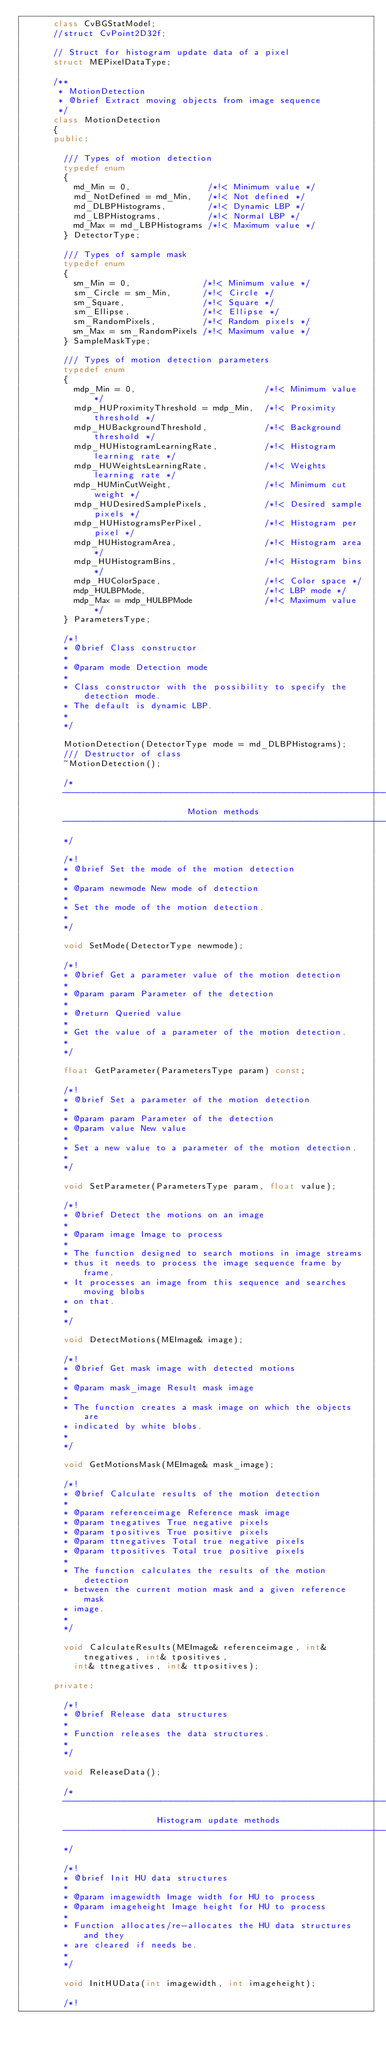Convert code to text. <code><loc_0><loc_0><loc_500><loc_500><_C++_>      class CvBGStatModel;
      //struct CvPoint2D32f;

      // Struct for histogram update data of a pixel
      struct MEPixelDataType;

      /**
       * MotionDetection
       * @brief Extract moving objects from image sequence
       */
      class MotionDetection
      {
      public:

        /// Types of motion detection
        typedef enum
        {
          md_Min = 0,               /*!< Minimum value */
          md_NotDefined = md_Min,   /*!< Not defined */
          md_DLBPHistograms,        /*!< Dynamic LBP */
          md_LBPHistograms,         /*!< Normal LBP */
          md_Max = md_LBPHistograms /*!< Maximum value */
        } DetectorType;

        /// Types of sample mask
        typedef enum
        {
          sm_Min = 0,              /*!< Minimum value */
          sm_Circle = sm_Min,      /*!< Circle */
          sm_Square,               /*!< Square */
          sm_Ellipse,              /*!< Ellipse */
          sm_RandomPixels,         /*!< Random pixels */
          sm_Max = sm_RandomPixels /*!< Maximum value */
        } SampleMaskType;

        /// Types of motion detection parameters
        typedef enum
        {
          mdp_Min = 0,                         /*!< Minimum value */
          mdp_HUProximityThreshold = mdp_Min,  /*!< Proximity threshold */
          mdp_HUBackgroundThreshold,           /*!< Background threshold */
          mdp_HUHistogramLearningRate,         /*!< Histogram learning rate */
          mdp_HUWeightsLearningRate,           /*!< Weights learning rate */
          mdp_HUMinCutWeight,                  /*!< Minimum cut weight */
          mdp_HUDesiredSamplePixels,           /*!< Desired sample pixels */
          mdp_HUHistogramsPerPixel,            /*!< Histogram per pixel */
          mdp_HUHistogramArea,                 /*!< Histogram area */
          mdp_HUHistogramBins,                 /*!< Histogram bins */
          mdp_HUColorSpace,                    /*!< Color space */
          mdp_HULBPMode,                       /*!< LBP mode */
          mdp_Max = mdp_HULBPMode              /*!< Maximum value */
        } ParametersType;

        /*!
        * @brief Class constructor
        *
        * @param mode Detection mode
        *
        * Class constructor with the possibility to specify the detection mode.
        * The default is dynamic LBP.
        *
        */

        MotionDetection(DetectorType mode = md_DLBPHistograms);
        /// Destructor of class
        ~MotionDetection();

        /*
        -------------------------------------------------------------------
                                Motion methods
        -------------------------------------------------------------------
        */

        /*!
        * @brief Set the mode of the motion detection
        *
        * @param newmode New mode of detection
        *
        * Set the mode of the motion detection.
        *
        */

        void SetMode(DetectorType newmode);

        /*!
        * @brief Get a parameter value of the motion detection
        *
        * @param param Parameter of the detection
        *
        * @return Queried value
        *
        * Get the value of a parameter of the motion detection.
        *
        */

        float GetParameter(ParametersType param) const;

        /*!
        * @brief Set a parameter of the motion detection
        *
        * @param param Parameter of the detection
        * @param value New value
        *
        * Set a new value to a parameter of the motion detection.
        *
        */

        void SetParameter(ParametersType param, float value);

        /*!
        * @brief Detect the motions on an image
        *
        * @param image Image to process
        *
        * The function designed to search motions in image streams
        * thus it needs to process the image sequence frame by frame.
        * It processes an image from this sequence and searches moving blobs
        * on that.
        *
        */

        void DetectMotions(MEImage& image);

        /*!
        * @brief Get mask image with detected motions
        *
        * @param mask_image Result mask image
        *
        * The function creates a mask image on which the objects are
        * indicated by white blobs.
        *
        */

        void GetMotionsMask(MEImage& mask_image);

        /*!
        * @brief Calculate results of the motion detection
        *
        * @param referenceimage Reference mask image
        * @param tnegatives True negative pixels
        * @param tpositives True positive pixels
        * @param ttnegatives Total true negative pixels
        * @param ttpositives Total true positive pixels
        *
        * The function calculates the results of the motion detection
        * between the current motion mask and a given reference mask
        * image.
        *
        */

        void CalculateResults(MEImage& referenceimage, int& tnegatives, int& tpositives,
          int& ttnegatives, int& ttpositives);

      private:

        /*!
        * @brief Release data structures
        *
        * Function releases the data structures.
        *
        */

        void ReleaseData();

        /*
        -------------------------------------------------------------------
                          Histogram update methods
        -------------------------------------------------------------------
        */

        /*!
        * @brief Init HU data structures
        *
        * @param imagewidth Image width for HU to process
        * @param imageheight Image height for HU to process
        *
        * Function allocates/re-allocates the HU data structures and they
        * are cleared if needs be.
        *
        */

        void InitHUData(int imagewidth, int imageheight);

        /*!</code> 